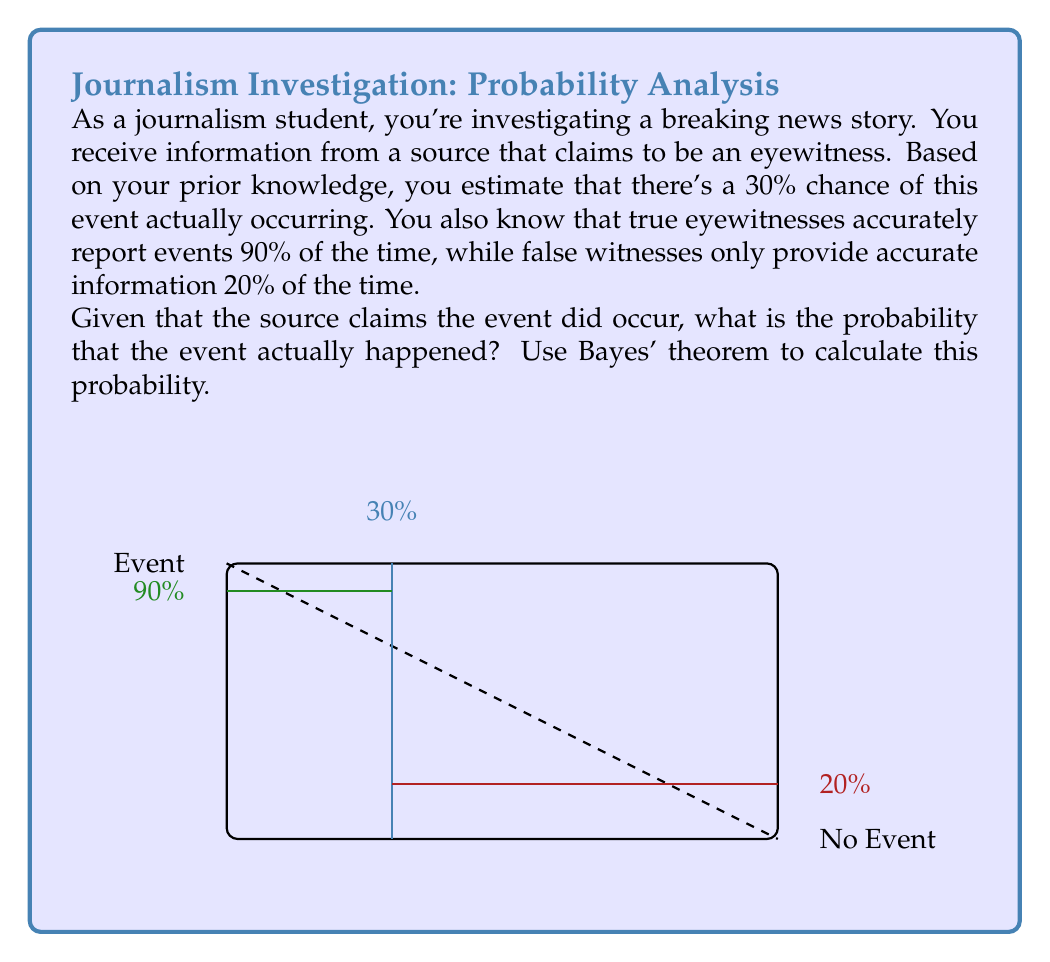Could you help me with this problem? Let's approach this problem step-by-step using Bayes' theorem:

1) Define our events:
   A: The event actually occurred
   B: The source claims the event occurred

2) Given probabilities:
   P(A) = 0.30 (prior probability of the event occurring)
   P(B|A) = 0.90 (probability of a true witness reporting accurately)
   P(B|not A) = 0.20 (probability of a false witness reporting the event occurred)

3) Bayes' theorem states:

   $$P(A|B) = \frac{P(B|A) \cdot P(A)}{P(B)}$$

4) We need to calculate P(B):
   P(B) = P(B|A) · P(A) + P(B|not A) · P(not A)
        = 0.90 · 0.30 + 0.20 · 0.70
        = 0.27 + 0.14
        = 0.41

5) Now we can apply Bayes' theorem:

   $$P(A|B) = \frac{0.90 \cdot 0.30}{0.41} = \frac{0.27}{0.41} \approx 0.6585$$

6) Convert to a percentage: 0.6585 * 100% ≈ 65.85%

Therefore, given that the source claims the event occurred, there is approximately a 65.85% chance that the event actually happened.
Answer: 65.85% 